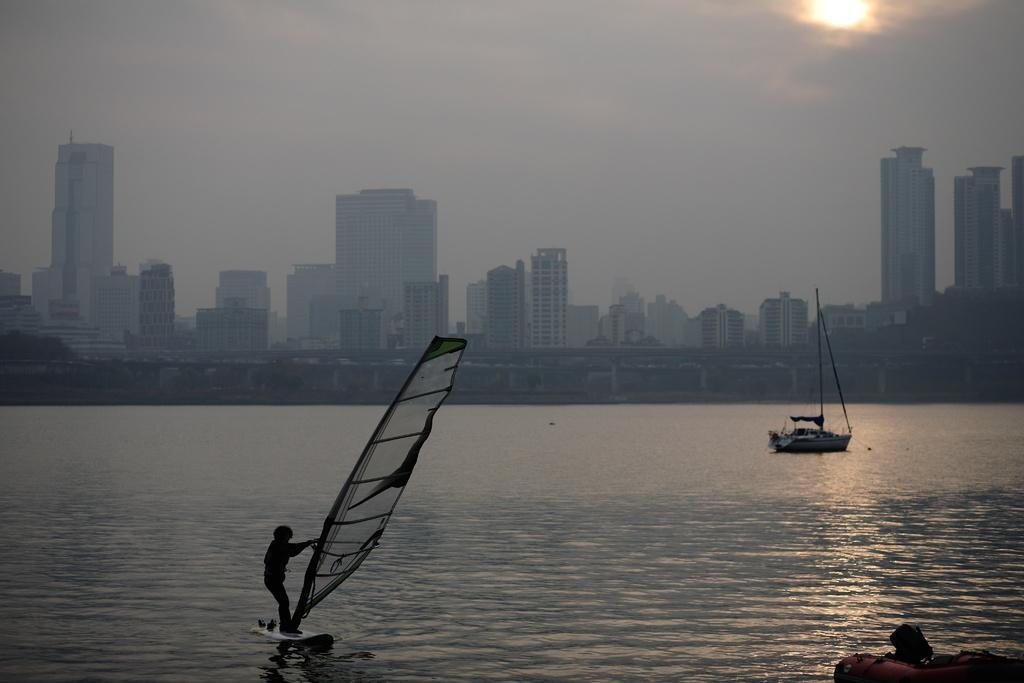Could you give a brief overview of what you see in this image? This picture is clicked outside. On the left we can see a person standing on the boat and holding some object. On the right we can see the boats in the water body. In the background we can see the sun in the sky and we can see the buildings, skyscrapers, trees and many other objects. 